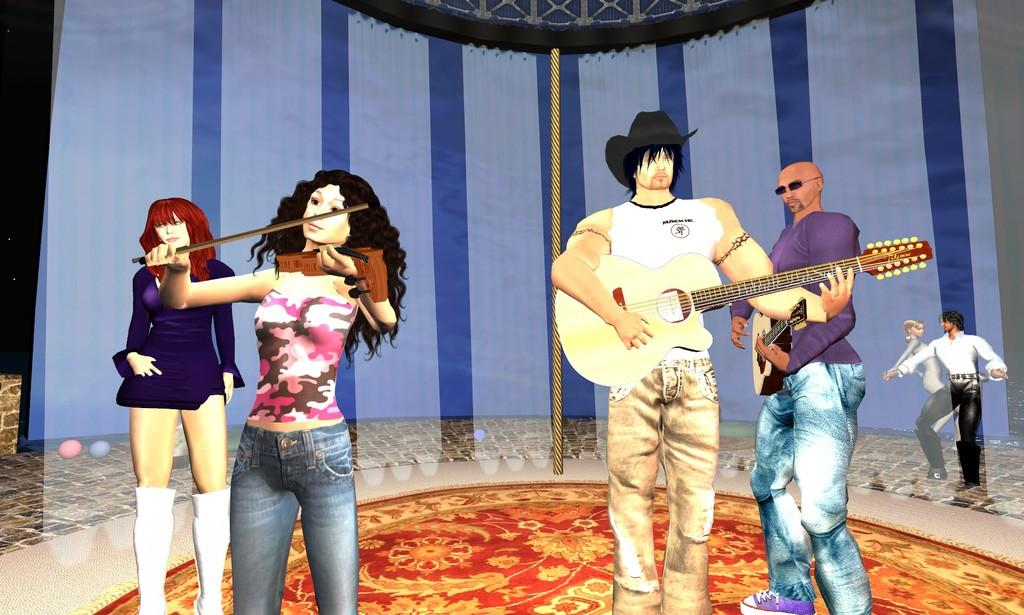What are the people in the image doing? The people in the image are playing musical instruments. What else can be seen happening in the background of the image? There is a man and a woman dancing in the background of the image. What is the purpose of the curtain in the image? The curtain in the image may be used for decoration or to separate different areas. What type of bear can be seen playing the drums in the image? There is no bear present in the image, and therefore no such activity can be observed. 